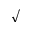<formula> <loc_0><loc_0><loc_500><loc_500>\surd</formula> 